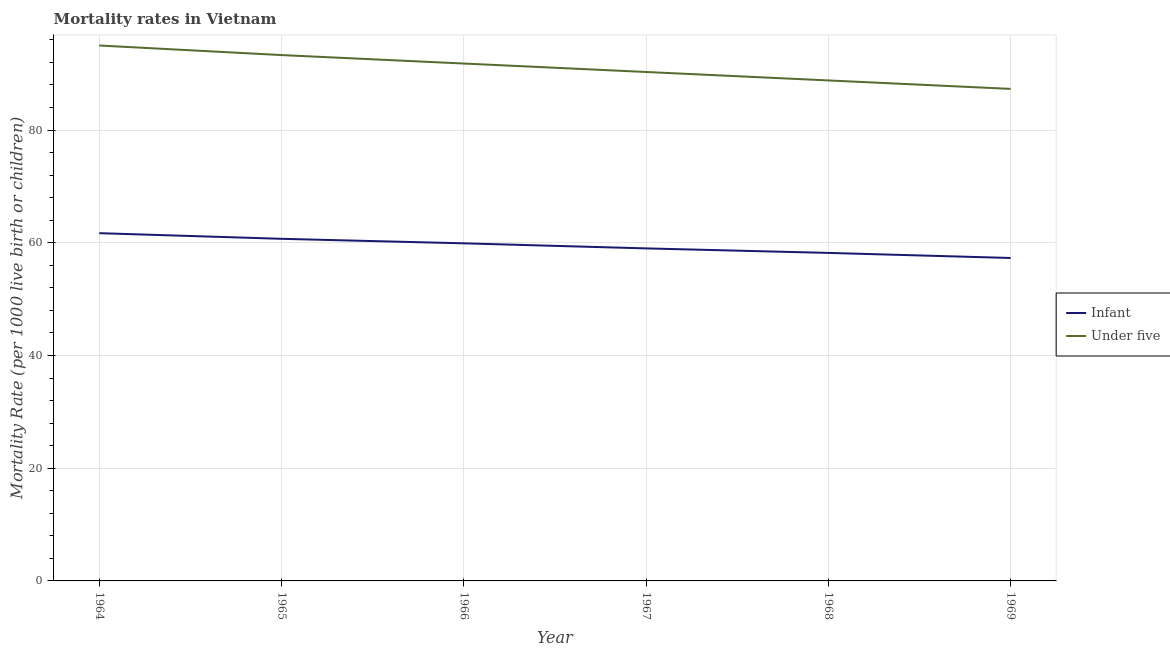How many different coloured lines are there?
Your answer should be very brief. 2. Is the number of lines equal to the number of legend labels?
Make the answer very short. Yes. What is the under-5 mortality rate in 1969?
Your answer should be compact. 87.3. Across all years, what is the minimum infant mortality rate?
Your answer should be very brief. 57.3. In which year was the infant mortality rate maximum?
Keep it short and to the point. 1964. In which year was the under-5 mortality rate minimum?
Offer a terse response. 1969. What is the total infant mortality rate in the graph?
Your response must be concise. 356.8. What is the difference between the infant mortality rate in 1967 and that in 1969?
Your response must be concise. 1.7. What is the difference between the under-5 mortality rate in 1966 and the infant mortality rate in 1967?
Your response must be concise. 32.8. What is the average infant mortality rate per year?
Your response must be concise. 59.47. In the year 1967, what is the difference between the under-5 mortality rate and infant mortality rate?
Make the answer very short. 31.3. In how many years, is the under-5 mortality rate greater than 72?
Give a very brief answer. 6. What is the ratio of the under-5 mortality rate in 1964 to that in 1968?
Offer a terse response. 1.07. Is the difference between the under-5 mortality rate in 1968 and 1969 greater than the difference between the infant mortality rate in 1968 and 1969?
Your response must be concise. Yes. What is the difference between the highest and the lowest infant mortality rate?
Your response must be concise. 4.4. In how many years, is the under-5 mortality rate greater than the average under-5 mortality rate taken over all years?
Offer a very short reply. 3. Does the under-5 mortality rate monotonically increase over the years?
Make the answer very short. No. Is the under-5 mortality rate strictly greater than the infant mortality rate over the years?
Offer a very short reply. Yes. Is the under-5 mortality rate strictly less than the infant mortality rate over the years?
Keep it short and to the point. No. What is the difference between two consecutive major ticks on the Y-axis?
Your response must be concise. 20. What is the title of the graph?
Offer a terse response. Mortality rates in Vietnam. What is the label or title of the Y-axis?
Your answer should be very brief. Mortality Rate (per 1000 live birth or children). What is the Mortality Rate (per 1000 live birth or children) in Infant in 1964?
Provide a short and direct response. 61.7. What is the Mortality Rate (per 1000 live birth or children) in Infant in 1965?
Provide a short and direct response. 60.7. What is the Mortality Rate (per 1000 live birth or children) of Under five in 1965?
Give a very brief answer. 93.3. What is the Mortality Rate (per 1000 live birth or children) in Infant in 1966?
Your answer should be compact. 59.9. What is the Mortality Rate (per 1000 live birth or children) of Under five in 1966?
Your answer should be compact. 91.8. What is the Mortality Rate (per 1000 live birth or children) of Infant in 1967?
Your response must be concise. 59. What is the Mortality Rate (per 1000 live birth or children) in Under five in 1967?
Offer a very short reply. 90.3. What is the Mortality Rate (per 1000 live birth or children) in Infant in 1968?
Provide a succinct answer. 58.2. What is the Mortality Rate (per 1000 live birth or children) in Under five in 1968?
Provide a succinct answer. 88.8. What is the Mortality Rate (per 1000 live birth or children) of Infant in 1969?
Offer a terse response. 57.3. What is the Mortality Rate (per 1000 live birth or children) of Under five in 1969?
Your answer should be very brief. 87.3. Across all years, what is the maximum Mortality Rate (per 1000 live birth or children) in Infant?
Your answer should be very brief. 61.7. Across all years, what is the minimum Mortality Rate (per 1000 live birth or children) of Infant?
Provide a short and direct response. 57.3. Across all years, what is the minimum Mortality Rate (per 1000 live birth or children) of Under five?
Ensure brevity in your answer.  87.3. What is the total Mortality Rate (per 1000 live birth or children) of Infant in the graph?
Your answer should be very brief. 356.8. What is the total Mortality Rate (per 1000 live birth or children) in Under five in the graph?
Provide a succinct answer. 546.5. What is the difference between the Mortality Rate (per 1000 live birth or children) of Under five in 1964 and that in 1965?
Your answer should be compact. 1.7. What is the difference between the Mortality Rate (per 1000 live birth or children) of Under five in 1964 and that in 1966?
Your response must be concise. 3.2. What is the difference between the Mortality Rate (per 1000 live birth or children) in Infant in 1964 and that in 1967?
Provide a succinct answer. 2.7. What is the difference between the Mortality Rate (per 1000 live birth or children) in Under five in 1964 and that in 1967?
Offer a terse response. 4.7. What is the difference between the Mortality Rate (per 1000 live birth or children) of Infant in 1964 and that in 1969?
Make the answer very short. 4.4. What is the difference between the Mortality Rate (per 1000 live birth or children) of Under five in 1964 and that in 1969?
Give a very brief answer. 7.7. What is the difference between the Mortality Rate (per 1000 live birth or children) in Infant in 1965 and that in 1966?
Offer a terse response. 0.8. What is the difference between the Mortality Rate (per 1000 live birth or children) of Under five in 1965 and that in 1967?
Give a very brief answer. 3. What is the difference between the Mortality Rate (per 1000 live birth or children) in Infant in 1965 and that in 1968?
Provide a succinct answer. 2.5. What is the difference between the Mortality Rate (per 1000 live birth or children) of Under five in 1965 and that in 1968?
Your response must be concise. 4.5. What is the difference between the Mortality Rate (per 1000 live birth or children) in Infant in 1965 and that in 1969?
Your response must be concise. 3.4. What is the difference between the Mortality Rate (per 1000 live birth or children) of Under five in 1965 and that in 1969?
Your answer should be very brief. 6. What is the difference between the Mortality Rate (per 1000 live birth or children) in Infant in 1966 and that in 1967?
Offer a very short reply. 0.9. What is the difference between the Mortality Rate (per 1000 live birth or children) of Under five in 1966 and that in 1967?
Your response must be concise. 1.5. What is the difference between the Mortality Rate (per 1000 live birth or children) in Infant in 1966 and that in 1968?
Offer a terse response. 1.7. What is the difference between the Mortality Rate (per 1000 live birth or children) of Under five in 1966 and that in 1968?
Provide a short and direct response. 3. What is the difference between the Mortality Rate (per 1000 live birth or children) of Infant in 1966 and that in 1969?
Your answer should be very brief. 2.6. What is the difference between the Mortality Rate (per 1000 live birth or children) in Under five in 1966 and that in 1969?
Give a very brief answer. 4.5. What is the difference between the Mortality Rate (per 1000 live birth or children) in Infant in 1967 and that in 1969?
Your answer should be very brief. 1.7. What is the difference between the Mortality Rate (per 1000 live birth or children) in Under five in 1967 and that in 1969?
Offer a terse response. 3. What is the difference between the Mortality Rate (per 1000 live birth or children) in Under five in 1968 and that in 1969?
Provide a short and direct response. 1.5. What is the difference between the Mortality Rate (per 1000 live birth or children) in Infant in 1964 and the Mortality Rate (per 1000 live birth or children) in Under five in 1965?
Keep it short and to the point. -31.6. What is the difference between the Mortality Rate (per 1000 live birth or children) of Infant in 1964 and the Mortality Rate (per 1000 live birth or children) of Under five in 1966?
Your response must be concise. -30.1. What is the difference between the Mortality Rate (per 1000 live birth or children) of Infant in 1964 and the Mortality Rate (per 1000 live birth or children) of Under five in 1967?
Provide a short and direct response. -28.6. What is the difference between the Mortality Rate (per 1000 live birth or children) in Infant in 1964 and the Mortality Rate (per 1000 live birth or children) in Under five in 1968?
Offer a very short reply. -27.1. What is the difference between the Mortality Rate (per 1000 live birth or children) in Infant in 1964 and the Mortality Rate (per 1000 live birth or children) in Under five in 1969?
Ensure brevity in your answer.  -25.6. What is the difference between the Mortality Rate (per 1000 live birth or children) of Infant in 1965 and the Mortality Rate (per 1000 live birth or children) of Under five in 1966?
Your response must be concise. -31.1. What is the difference between the Mortality Rate (per 1000 live birth or children) in Infant in 1965 and the Mortality Rate (per 1000 live birth or children) in Under five in 1967?
Make the answer very short. -29.6. What is the difference between the Mortality Rate (per 1000 live birth or children) in Infant in 1965 and the Mortality Rate (per 1000 live birth or children) in Under five in 1968?
Keep it short and to the point. -28.1. What is the difference between the Mortality Rate (per 1000 live birth or children) in Infant in 1965 and the Mortality Rate (per 1000 live birth or children) in Under five in 1969?
Offer a very short reply. -26.6. What is the difference between the Mortality Rate (per 1000 live birth or children) in Infant in 1966 and the Mortality Rate (per 1000 live birth or children) in Under five in 1967?
Ensure brevity in your answer.  -30.4. What is the difference between the Mortality Rate (per 1000 live birth or children) in Infant in 1966 and the Mortality Rate (per 1000 live birth or children) in Under five in 1968?
Keep it short and to the point. -28.9. What is the difference between the Mortality Rate (per 1000 live birth or children) of Infant in 1966 and the Mortality Rate (per 1000 live birth or children) of Under five in 1969?
Offer a terse response. -27.4. What is the difference between the Mortality Rate (per 1000 live birth or children) of Infant in 1967 and the Mortality Rate (per 1000 live birth or children) of Under five in 1968?
Offer a terse response. -29.8. What is the difference between the Mortality Rate (per 1000 live birth or children) in Infant in 1967 and the Mortality Rate (per 1000 live birth or children) in Under five in 1969?
Keep it short and to the point. -28.3. What is the difference between the Mortality Rate (per 1000 live birth or children) of Infant in 1968 and the Mortality Rate (per 1000 live birth or children) of Under five in 1969?
Provide a succinct answer. -29.1. What is the average Mortality Rate (per 1000 live birth or children) of Infant per year?
Keep it short and to the point. 59.47. What is the average Mortality Rate (per 1000 live birth or children) of Under five per year?
Your response must be concise. 91.08. In the year 1964, what is the difference between the Mortality Rate (per 1000 live birth or children) in Infant and Mortality Rate (per 1000 live birth or children) in Under five?
Offer a very short reply. -33.3. In the year 1965, what is the difference between the Mortality Rate (per 1000 live birth or children) of Infant and Mortality Rate (per 1000 live birth or children) of Under five?
Provide a succinct answer. -32.6. In the year 1966, what is the difference between the Mortality Rate (per 1000 live birth or children) in Infant and Mortality Rate (per 1000 live birth or children) in Under five?
Give a very brief answer. -31.9. In the year 1967, what is the difference between the Mortality Rate (per 1000 live birth or children) of Infant and Mortality Rate (per 1000 live birth or children) of Under five?
Your answer should be very brief. -31.3. In the year 1968, what is the difference between the Mortality Rate (per 1000 live birth or children) in Infant and Mortality Rate (per 1000 live birth or children) in Under five?
Offer a terse response. -30.6. What is the ratio of the Mortality Rate (per 1000 live birth or children) in Infant in 1964 to that in 1965?
Offer a terse response. 1.02. What is the ratio of the Mortality Rate (per 1000 live birth or children) of Under five in 1964 to that in 1965?
Keep it short and to the point. 1.02. What is the ratio of the Mortality Rate (per 1000 live birth or children) of Infant in 1964 to that in 1966?
Your response must be concise. 1.03. What is the ratio of the Mortality Rate (per 1000 live birth or children) in Under five in 1964 to that in 1966?
Your answer should be compact. 1.03. What is the ratio of the Mortality Rate (per 1000 live birth or children) in Infant in 1964 to that in 1967?
Your response must be concise. 1.05. What is the ratio of the Mortality Rate (per 1000 live birth or children) in Under five in 1964 to that in 1967?
Make the answer very short. 1.05. What is the ratio of the Mortality Rate (per 1000 live birth or children) in Infant in 1964 to that in 1968?
Your response must be concise. 1.06. What is the ratio of the Mortality Rate (per 1000 live birth or children) of Under five in 1964 to that in 1968?
Offer a very short reply. 1.07. What is the ratio of the Mortality Rate (per 1000 live birth or children) in Infant in 1964 to that in 1969?
Provide a short and direct response. 1.08. What is the ratio of the Mortality Rate (per 1000 live birth or children) of Under five in 1964 to that in 1969?
Offer a terse response. 1.09. What is the ratio of the Mortality Rate (per 1000 live birth or children) in Infant in 1965 to that in 1966?
Make the answer very short. 1.01. What is the ratio of the Mortality Rate (per 1000 live birth or children) of Under five in 1965 to that in 1966?
Give a very brief answer. 1.02. What is the ratio of the Mortality Rate (per 1000 live birth or children) of Infant in 1965 to that in 1967?
Ensure brevity in your answer.  1.03. What is the ratio of the Mortality Rate (per 1000 live birth or children) of Under five in 1965 to that in 1967?
Provide a short and direct response. 1.03. What is the ratio of the Mortality Rate (per 1000 live birth or children) of Infant in 1965 to that in 1968?
Provide a succinct answer. 1.04. What is the ratio of the Mortality Rate (per 1000 live birth or children) in Under five in 1965 to that in 1968?
Your answer should be very brief. 1.05. What is the ratio of the Mortality Rate (per 1000 live birth or children) in Infant in 1965 to that in 1969?
Your answer should be compact. 1.06. What is the ratio of the Mortality Rate (per 1000 live birth or children) of Under five in 1965 to that in 1969?
Give a very brief answer. 1.07. What is the ratio of the Mortality Rate (per 1000 live birth or children) of Infant in 1966 to that in 1967?
Give a very brief answer. 1.02. What is the ratio of the Mortality Rate (per 1000 live birth or children) in Under five in 1966 to that in 1967?
Make the answer very short. 1.02. What is the ratio of the Mortality Rate (per 1000 live birth or children) in Infant in 1966 to that in 1968?
Ensure brevity in your answer.  1.03. What is the ratio of the Mortality Rate (per 1000 live birth or children) in Under five in 1966 to that in 1968?
Your answer should be compact. 1.03. What is the ratio of the Mortality Rate (per 1000 live birth or children) of Infant in 1966 to that in 1969?
Give a very brief answer. 1.05. What is the ratio of the Mortality Rate (per 1000 live birth or children) in Under five in 1966 to that in 1969?
Give a very brief answer. 1.05. What is the ratio of the Mortality Rate (per 1000 live birth or children) of Infant in 1967 to that in 1968?
Your answer should be very brief. 1.01. What is the ratio of the Mortality Rate (per 1000 live birth or children) in Under five in 1967 to that in 1968?
Provide a succinct answer. 1.02. What is the ratio of the Mortality Rate (per 1000 live birth or children) of Infant in 1967 to that in 1969?
Ensure brevity in your answer.  1.03. What is the ratio of the Mortality Rate (per 1000 live birth or children) of Under five in 1967 to that in 1969?
Keep it short and to the point. 1.03. What is the ratio of the Mortality Rate (per 1000 live birth or children) in Infant in 1968 to that in 1969?
Your response must be concise. 1.02. What is the ratio of the Mortality Rate (per 1000 live birth or children) in Under five in 1968 to that in 1969?
Your response must be concise. 1.02. What is the difference between the highest and the lowest Mortality Rate (per 1000 live birth or children) in Infant?
Give a very brief answer. 4.4. What is the difference between the highest and the lowest Mortality Rate (per 1000 live birth or children) of Under five?
Make the answer very short. 7.7. 